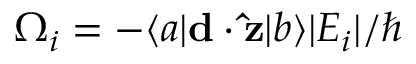Convert formula to latex. <formula><loc_0><loc_0><loc_500><loc_500>\Omega _ { i } = - \langle a | d \cdot \hat { z } | b \rangle | E _ { i } | / \hbar</formula> 